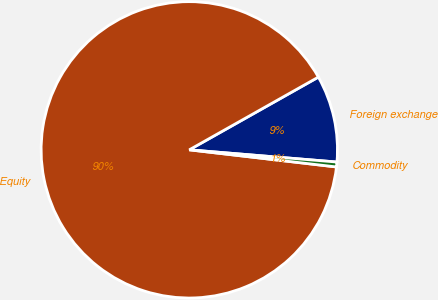Convert chart. <chart><loc_0><loc_0><loc_500><loc_500><pie_chart><fcel>Foreign exchange<fcel>Equity<fcel>Commodity<nl><fcel>9.48%<fcel>89.99%<fcel>0.53%<nl></chart> 